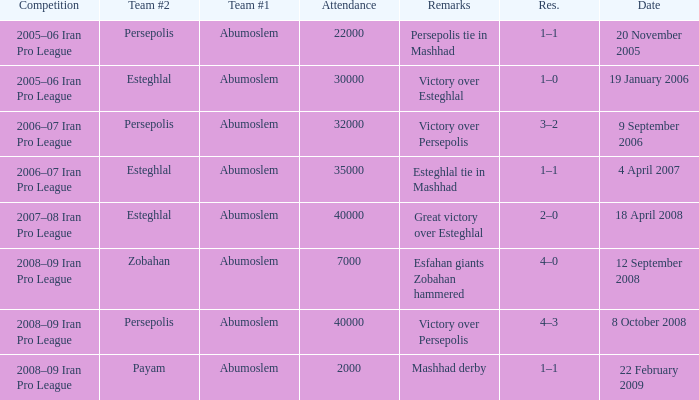What was the res for the game against Payam? 1–1. 